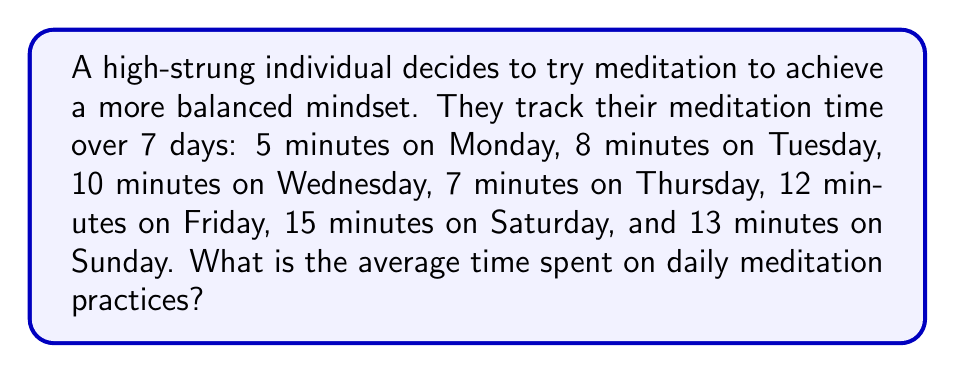Could you help me with this problem? To find the average time spent on daily meditation practices, we need to:

1. Sum up the total meditation time for all 7 days
2. Divide the total time by the number of days

Step 1: Calculate the total meditation time
$$ \text{Total time} = 5 + 8 + 10 + 7 + 12 + 15 + 13 = 70 \text{ minutes} $$

Step 2: Divide the total time by the number of days
$$ \text{Average time} = \frac{\text{Total time}}{\text{Number of days}} = \frac{70 \text{ minutes}}{7 \text{ days}} = 10 \text{ minutes per day} $$

Therefore, the average time spent on daily meditation practices is 10 minutes per day.
Answer: 10 minutes 